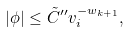Convert formula to latex. <formula><loc_0><loc_0><loc_500><loc_500>| \phi | \leq \tilde { C } ^ { \prime \prime } v _ { i } ^ { - w _ { k + 1 } } ,</formula> 